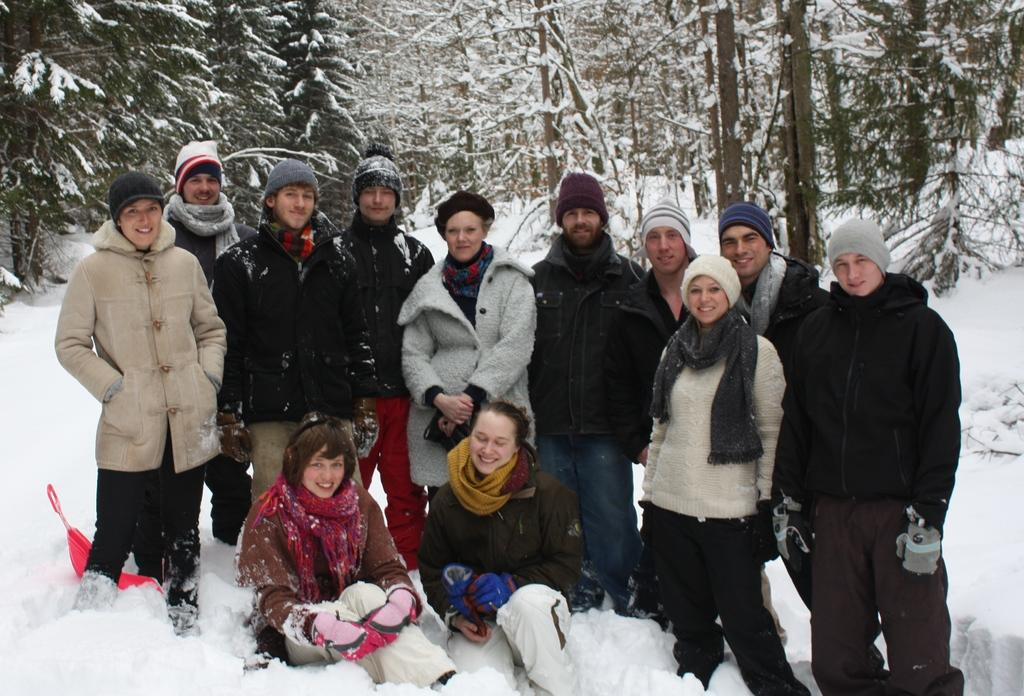How many people are in the image? There are many people in the image. What are the people wearing in the image? The people are wearing jackets. Where does the image appear to be taken? The image appears to be taken in a forest. What is visible at the bottom of the image? There is a floor visible at the bottom of the image. Can you see a snail crawling on the chin of one of the people in the image? There is no snail or chin visible in the image; it features people wearing jackets in a forest setting. 